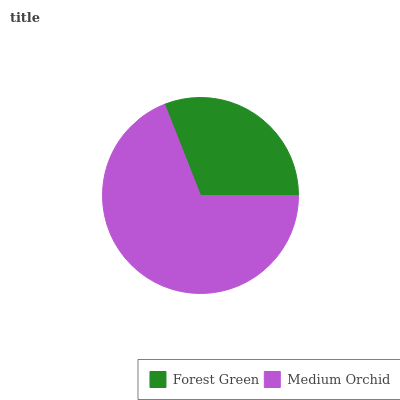Is Forest Green the minimum?
Answer yes or no. Yes. Is Medium Orchid the maximum?
Answer yes or no. Yes. Is Medium Orchid the minimum?
Answer yes or no. No. Is Medium Orchid greater than Forest Green?
Answer yes or no. Yes. Is Forest Green less than Medium Orchid?
Answer yes or no. Yes. Is Forest Green greater than Medium Orchid?
Answer yes or no. No. Is Medium Orchid less than Forest Green?
Answer yes or no. No. Is Medium Orchid the high median?
Answer yes or no. Yes. Is Forest Green the low median?
Answer yes or no. Yes. Is Forest Green the high median?
Answer yes or no. No. Is Medium Orchid the low median?
Answer yes or no. No. 